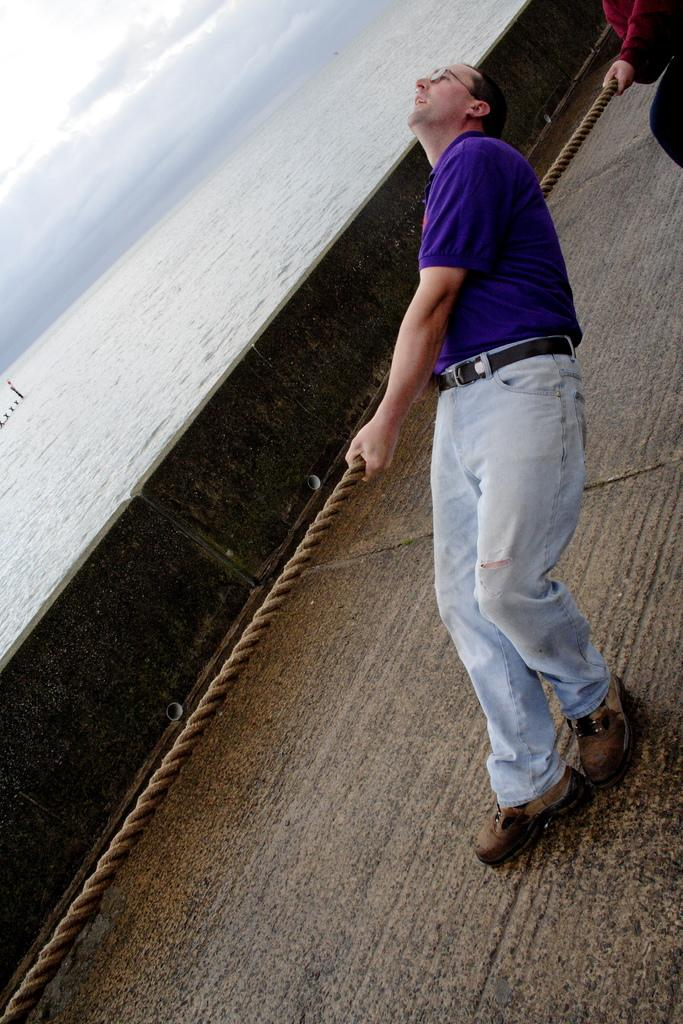How many people are in the image? There are two people in the image. What are the two people doing in the image? The two people are pulling a rope. What type of surface are the people standing on? The people are standing on a wooden surface. What can be seen in the background of the image? There is a water surface visible in the image. What type of door can be seen in the image? There is no door present in the image. What error is being made by the people in the image? There is no error being made by the people in the image; they are simply pulling a rope. 